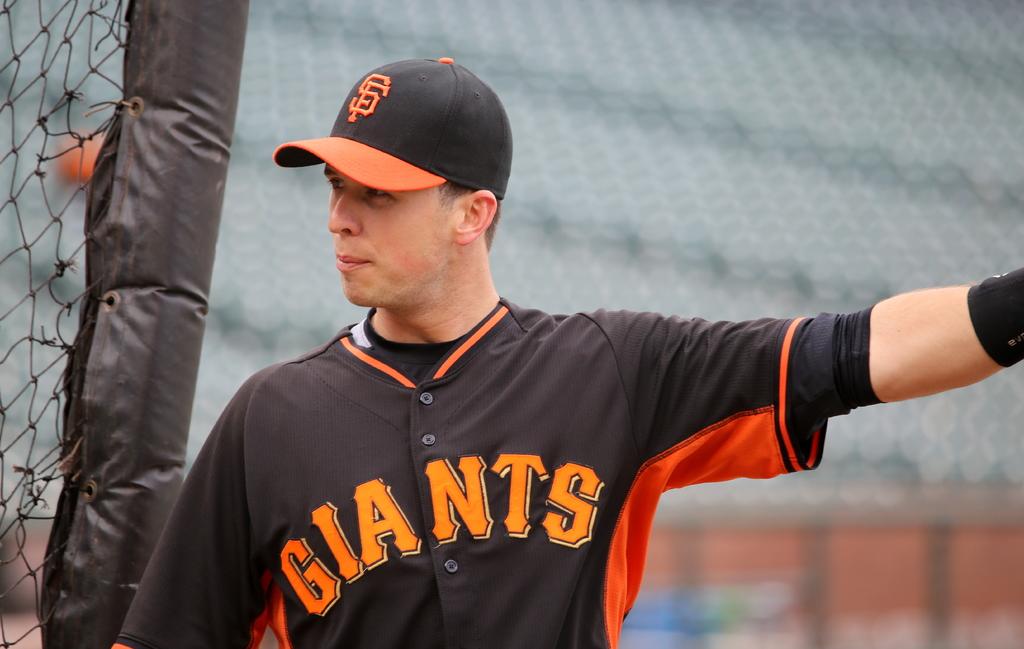Who does he play for?
Your response must be concise. Giants. Giants baseball team?
Provide a succinct answer. Yes. 